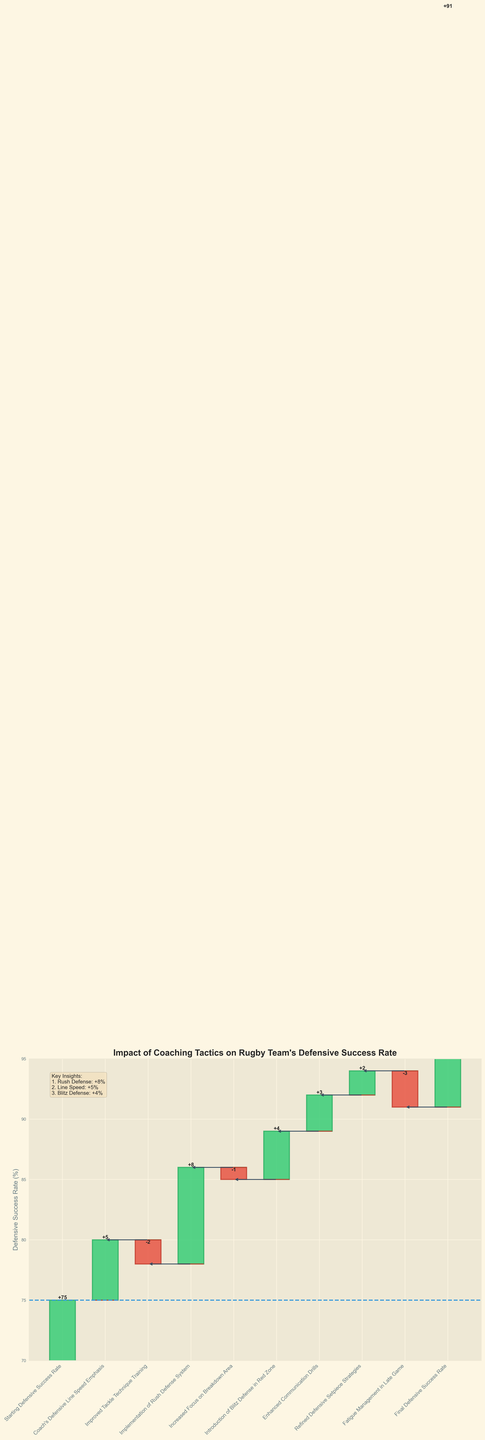What is the starting defensive success rate? The starting defensive success rate is the first value displayed on the chart, typically at the far left. The label "Starting Defensive Success Rate" has a corresponding value of 75%.
Answer: 75% What is the final defensive success rate achieved? The final defensive success rate is located at the far right of the chart under the label "Final Defensive Success Rate," with a corresponding value of 91%.
Answer: 91% How much did the introduction of the Rush Defense System contribute to the defensive success rate? The contribution of each coaching tactic is displayed as a change in value. The "Implementation of Rush Defense System" shows an increase of +8%.
Answer: +8% What is the combined impact of the Improved Tackle Technique Training and Fatigue Management in Late Game on the defensive success rate? These two categories show contributions of -2% and -3% respectively. Summing them together: -2% + (-3%) = -5%.
Answer: -5% Which coaching tactic resulted in the greatest positive change in defensive success rate? Reviewing the values associated with each tactic, the "Implementation of Rush Defense System" resulted in the highest positive change with +8%.
Answer: Rush Defense System What’s the total contribution of all positive changes on the defensive success rate? Adding up all positive changes: +5% (Line Speed) +8% (Rush Defense) +4% (Blitz Defense) +3% (Communication Drills) +2% (Setpiece Strategies) = +22%.
Answer: +22% How many tactics negatively impacted the defensive success rate? There are two tactics with negative changes: "Improved Tackle Technique Training" (-2%) and "Fatigue Management in Late Game" (-3%). Thus, two tactics negatively impacted the rate.
Answer: 2 How much did the Increased Focus on Breakdown Area affect the defensive success rate? The "Increased Focus on Breakdown Area" is labeled with a change of -1%.
Answer: -1% What is the net change in the defensive success rate due to all the coaching tactics combined? The net change is the difference between the final and starting defensive success rates. Final (91%) - Starting (75%) = 16%.
Answer: 16% Which coaching tactic had the least impact on the defensive success rate, excluding those with no impact? The "Increased Focus on Breakdown Area" had a change of -1%, which is the smallest absolute value among the impacts listed.
Answer: Breakdown Area 